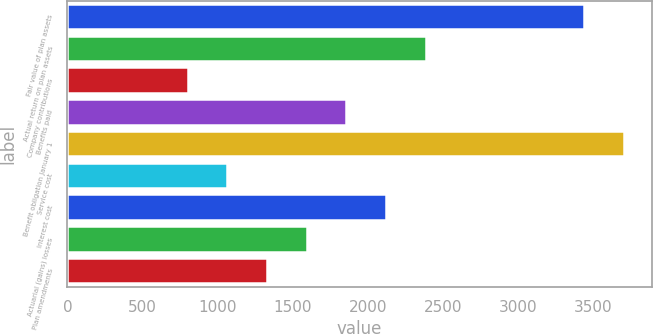Convert chart to OTSL. <chart><loc_0><loc_0><loc_500><loc_500><bar_chart><fcel>Fair value of plan assets<fcel>Actual return on plan assets<fcel>Company contributions<fcel>Benefits paid<fcel>Benefit obligation January 1<fcel>Service cost<fcel>Interest cost<fcel>Actuarial (gains) losses<fcel>Plan amendments<nl><fcel>3442.3<fcel>2385.9<fcel>801.3<fcel>1857.7<fcel>3706.4<fcel>1065.4<fcel>2121.8<fcel>1593.6<fcel>1329.5<nl></chart> 